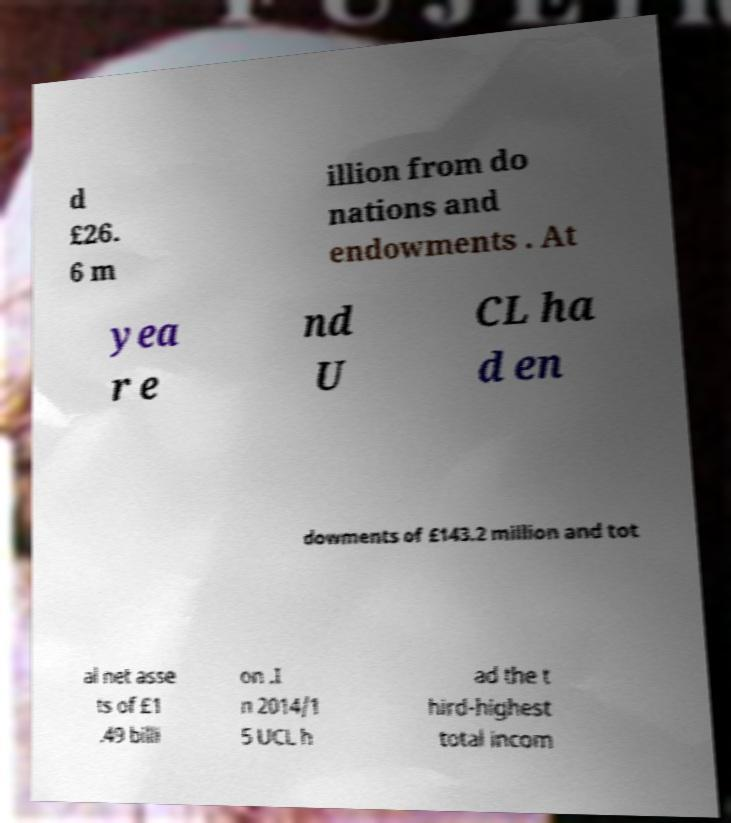Please read and relay the text visible in this image. What does it say? d £26. 6 m illion from do nations and endowments . At yea r e nd U CL ha d en dowments of £143.2 million and tot al net asse ts of £1 .49 billi on .I n 2014/1 5 UCL h ad the t hird-highest total incom 